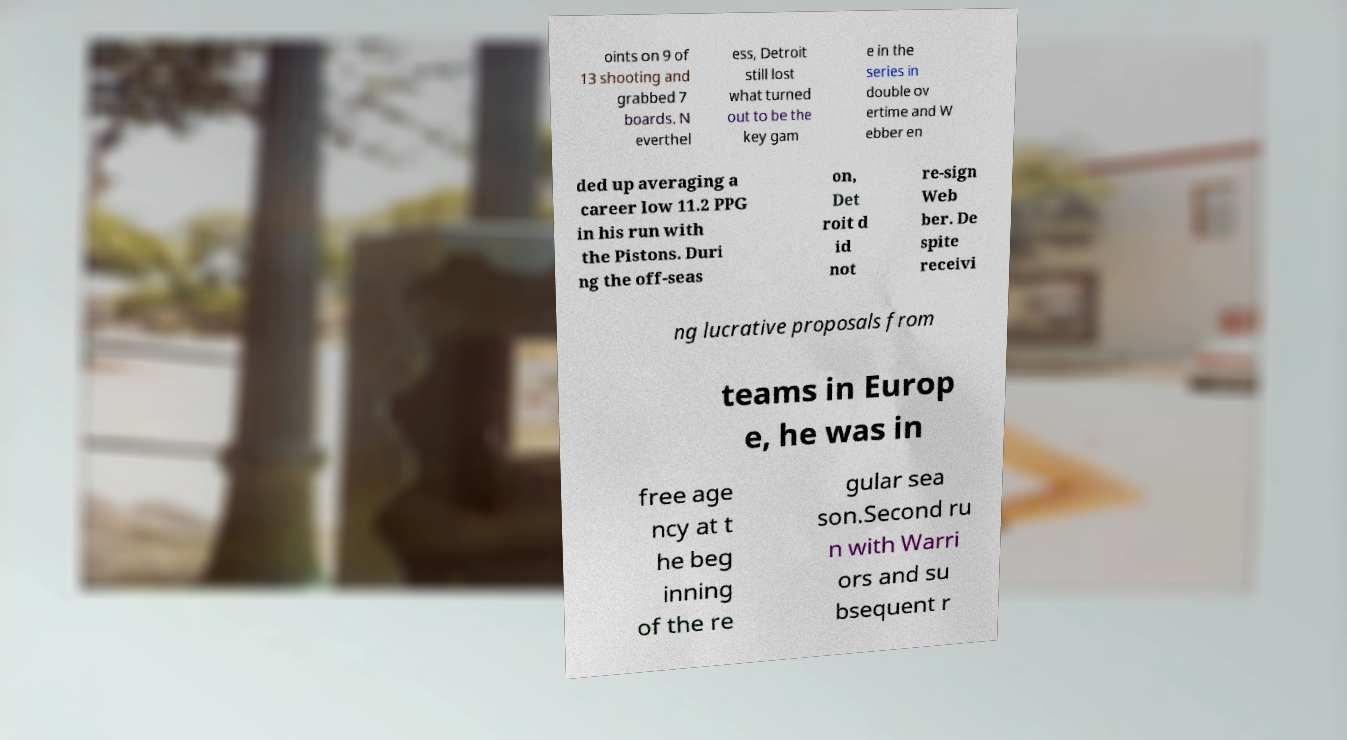For documentation purposes, I need the text within this image transcribed. Could you provide that? oints on 9 of 13 shooting and grabbed 7 boards. N everthel ess, Detroit still lost what turned out to be the key gam e in the series in double ov ertime and W ebber en ded up averaging a career low 11.2 PPG in his run with the Pistons. Duri ng the off-seas on, Det roit d id not re-sign Web ber. De spite receivi ng lucrative proposals from teams in Europ e, he was in free age ncy at t he beg inning of the re gular sea son.Second ru n with Warri ors and su bsequent r 